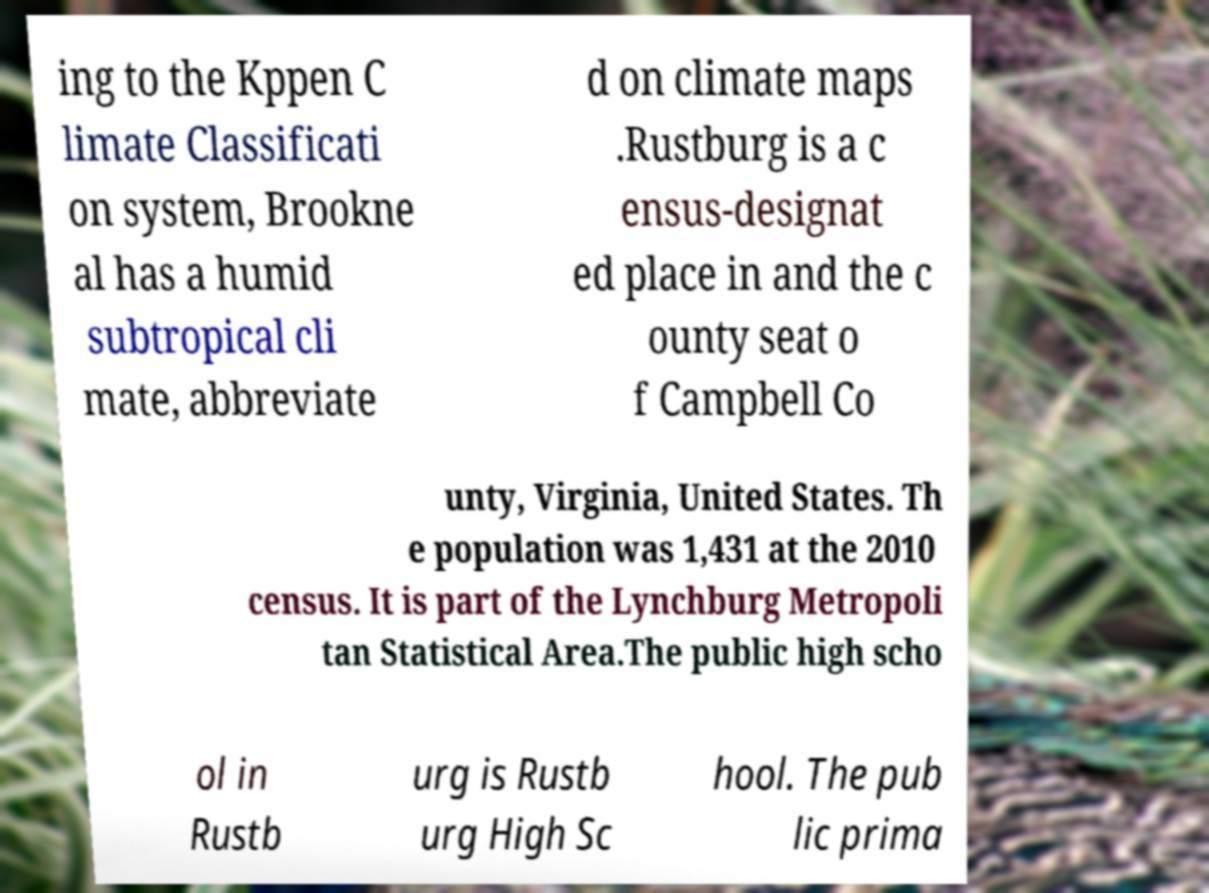I need the written content from this picture converted into text. Can you do that? ing to the Kppen C limate Classificati on system, Brookne al has a humid subtropical cli mate, abbreviate d on climate maps .Rustburg is a c ensus-designat ed place in and the c ounty seat o f Campbell Co unty, Virginia, United States. Th e population was 1,431 at the 2010 census. It is part of the Lynchburg Metropoli tan Statistical Area.The public high scho ol in Rustb urg is Rustb urg High Sc hool. The pub lic prima 